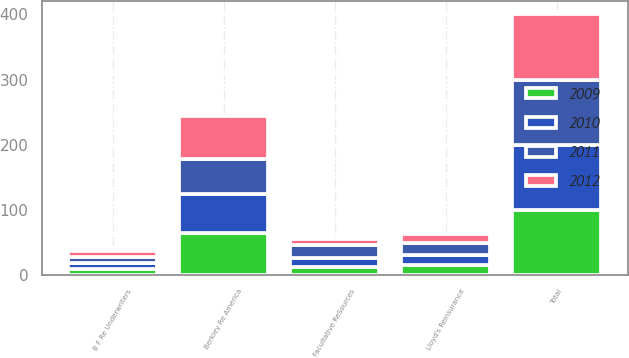Convert chart. <chart><loc_0><loc_0><loc_500><loc_500><stacked_bar_chart><ecel><fcel>Berkley Re America<fcel>Lloyd's Reinsurance<fcel>Facultative ReSources<fcel>B F Re Underwriters<fcel>Total<nl><fcel>2009<fcel>64.6<fcel>14.8<fcel>11.8<fcel>8.8<fcel>100<nl><fcel>2012<fcel>66.1<fcel>13.9<fcel>10.5<fcel>9.5<fcel>100<nl><fcel>2010<fcel>60.3<fcel>15.9<fcel>14.2<fcel>9.6<fcel>100<nl><fcel>2011<fcel>52.4<fcel>18.8<fcel>19.4<fcel>9.4<fcel>100<nl></chart> 